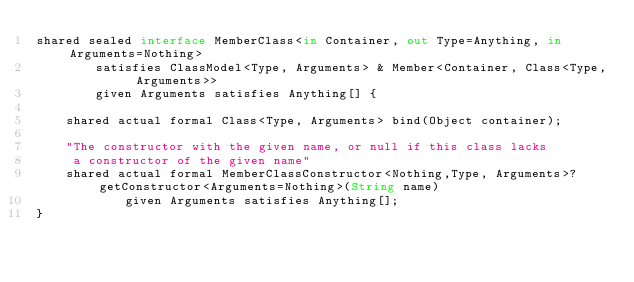Convert code to text. <code><loc_0><loc_0><loc_500><loc_500><_Ceylon_>shared sealed interface MemberClass<in Container, out Type=Anything, in Arguments=Nothing>
        satisfies ClassModel<Type, Arguments> & Member<Container, Class<Type, Arguments>>
        given Arguments satisfies Anything[] {
    
    shared actual formal Class<Type, Arguments> bind(Object container);
    
    "The constructor with the given name, or null if this class lacks 
     a constructor of the given name"
    shared actual formal MemberClassConstructor<Nothing,Type, Arguments>? getConstructor<Arguments=Nothing>(String name)
            given Arguments satisfies Anything[];
}
</code> 